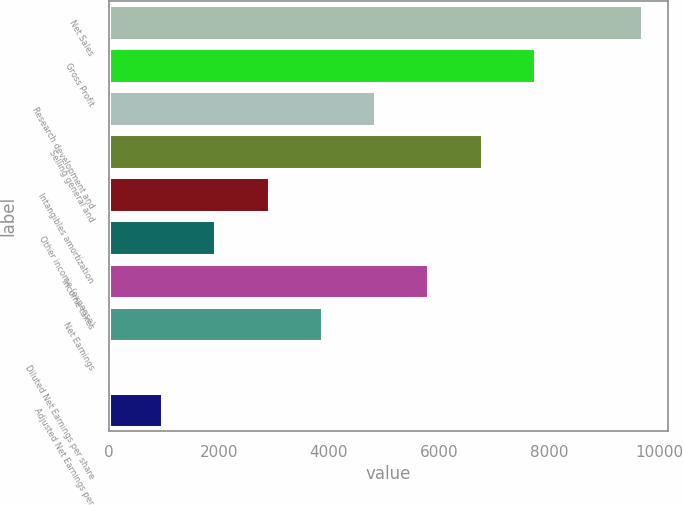<chart> <loc_0><loc_0><loc_500><loc_500><bar_chart><fcel>Net Sales<fcel>Gross Profit<fcel>Research development and<fcel>Selling general and<fcel>Intangibles amortization<fcel>Other income (expense)<fcel>Income taxes<fcel>Net Earnings<fcel>Diluted Net Earnings per share<fcel>Adjusted Net Earnings per<nl><fcel>9675<fcel>7740.3<fcel>4838.19<fcel>6772.93<fcel>2903.45<fcel>1936.08<fcel>5805.56<fcel>3870.82<fcel>1.34<fcel>968.71<nl></chart> 